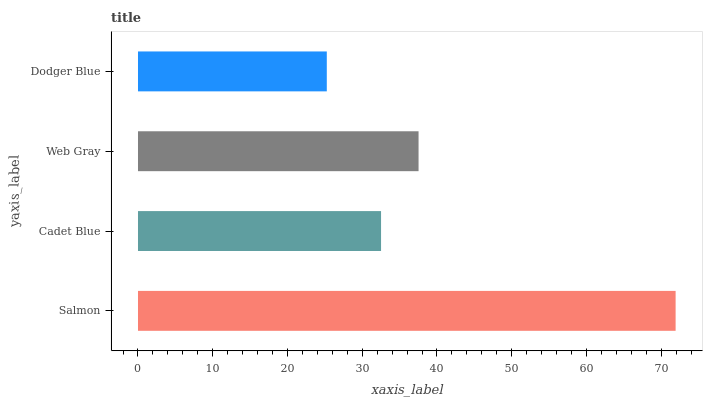Is Dodger Blue the minimum?
Answer yes or no. Yes. Is Salmon the maximum?
Answer yes or no. Yes. Is Cadet Blue the minimum?
Answer yes or no. No. Is Cadet Blue the maximum?
Answer yes or no. No. Is Salmon greater than Cadet Blue?
Answer yes or no. Yes. Is Cadet Blue less than Salmon?
Answer yes or no. Yes. Is Cadet Blue greater than Salmon?
Answer yes or no. No. Is Salmon less than Cadet Blue?
Answer yes or no. No. Is Web Gray the high median?
Answer yes or no. Yes. Is Cadet Blue the low median?
Answer yes or no. Yes. Is Salmon the high median?
Answer yes or no. No. Is Web Gray the low median?
Answer yes or no. No. 